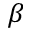<formula> <loc_0><loc_0><loc_500><loc_500>\beta</formula> 